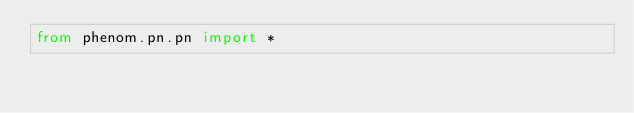<code> <loc_0><loc_0><loc_500><loc_500><_Python_>from phenom.pn.pn import *
</code> 